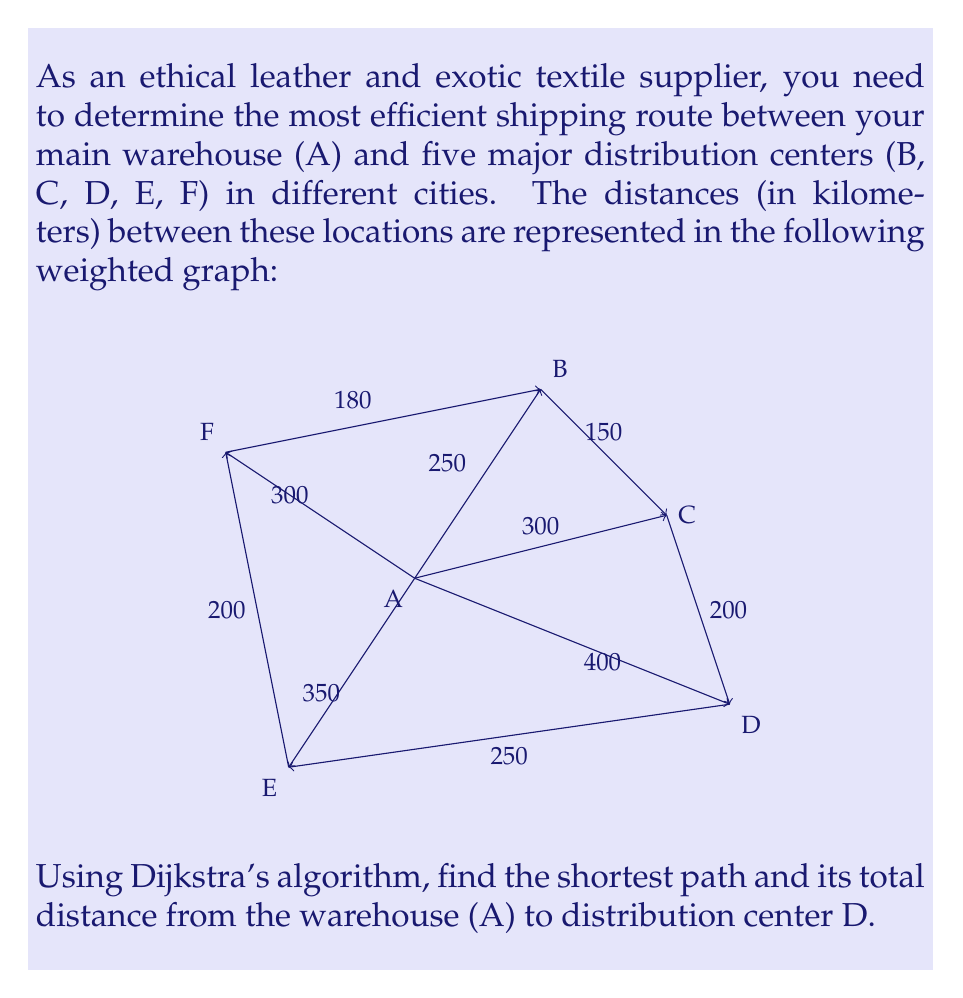Show me your answer to this math problem. To solve this problem, we'll apply Dijkstra's algorithm to find the shortest path from A to D. Here's a step-by-step explanation:

1) Initialize:
   - Set distance to A as 0
   - Set distances to all other nodes as infinity
   - Set A as the current node

2) Update distances to neighbors of A:
   - A to B: 250
   - A to C: 300
   - A to D: 400
   - A to E: 350
   - A to F: 300

3) Mark A as visited. Select the unvisited node with the smallest distance (B, 250km) as the new current node.

4) Update distances through B:
   - B to C: 250 + 150 = 400 > 300, no update
   - B to F: 250 + 180 = 430 > 300, no update

5) Mark B as visited. Select C (300km) as the new current node.

6) Update distances through C:
   - C to D: 300 + 200 = 500 < 400, update D to 500

7) Mark C as visited. Select F (300km) as the new current node.

8) No updates through F. Mark F as visited. Select E (350km) as the new current node.

9) Update distances through E:
   - E to D: 350 + 250 = 600 > 500, no update

10) Mark E as visited. Select D (500km) as the new current node.

11) All nodes visited or D reached. Algorithm terminates.

The shortest path from A to D is A → C → D with a total distance of 500km.
Answer: A → C → D, 500km 